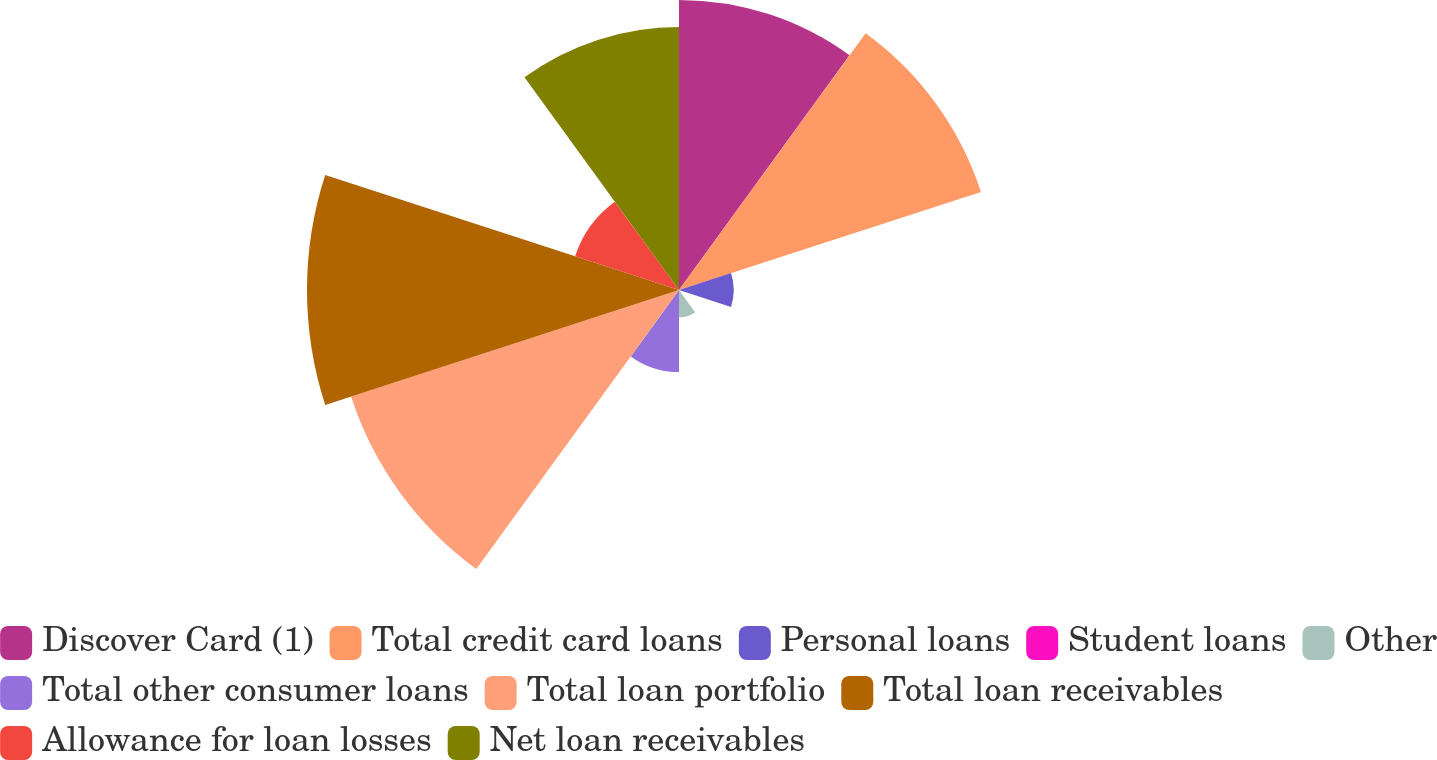Convert chart to OTSL. <chart><loc_0><loc_0><loc_500><loc_500><pie_chart><fcel>Discover Card (1)<fcel>Total credit card loans<fcel>Personal loans<fcel>Student loans<fcel>Other<fcel>Total other consumer loans<fcel>Total loan portfolio<fcel>Total loan receivables<fcel>Allowance for loan losses<fcel>Net loan receivables<nl><fcel>15.59%<fcel>17.06%<fcel>2.94%<fcel>0.01%<fcel>1.47%<fcel>4.41%<fcel>18.53%<fcel>19.99%<fcel>5.87%<fcel>14.13%<nl></chart> 